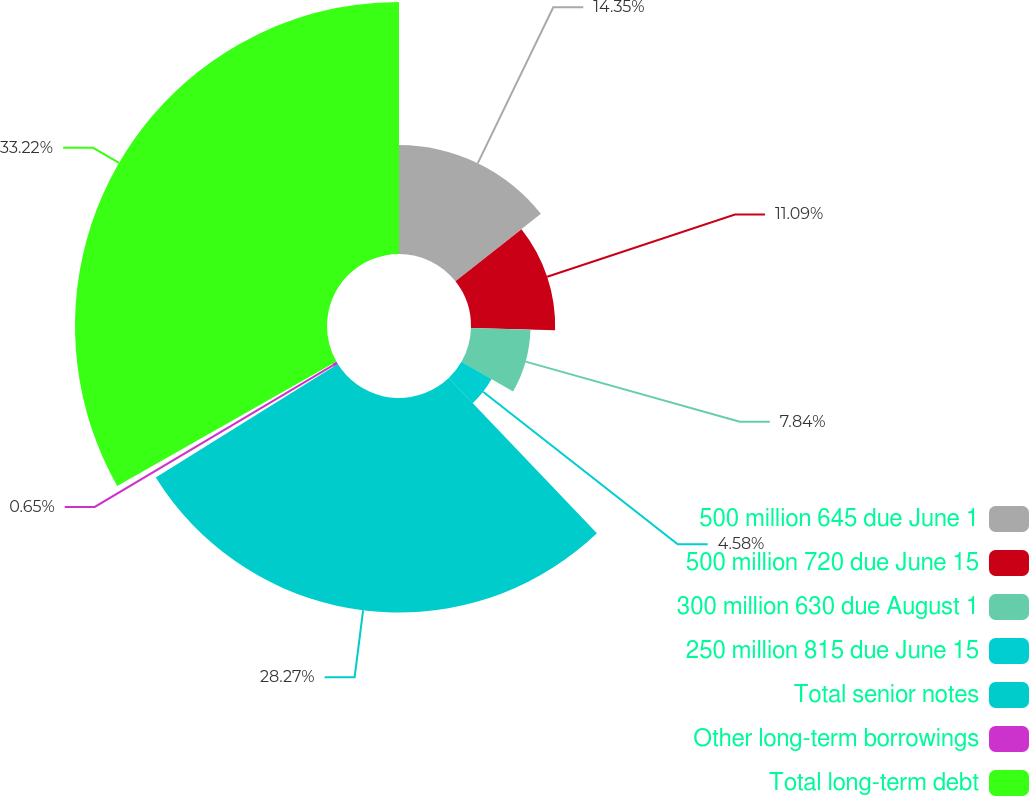Convert chart. <chart><loc_0><loc_0><loc_500><loc_500><pie_chart><fcel>500 million 645 due June 1<fcel>500 million 720 due June 15<fcel>300 million 630 due August 1<fcel>250 million 815 due June 15<fcel>Total senior notes<fcel>Other long-term borrowings<fcel>Total long-term debt<nl><fcel>14.35%<fcel>11.09%<fcel>7.84%<fcel>4.58%<fcel>28.27%<fcel>0.65%<fcel>33.21%<nl></chart> 